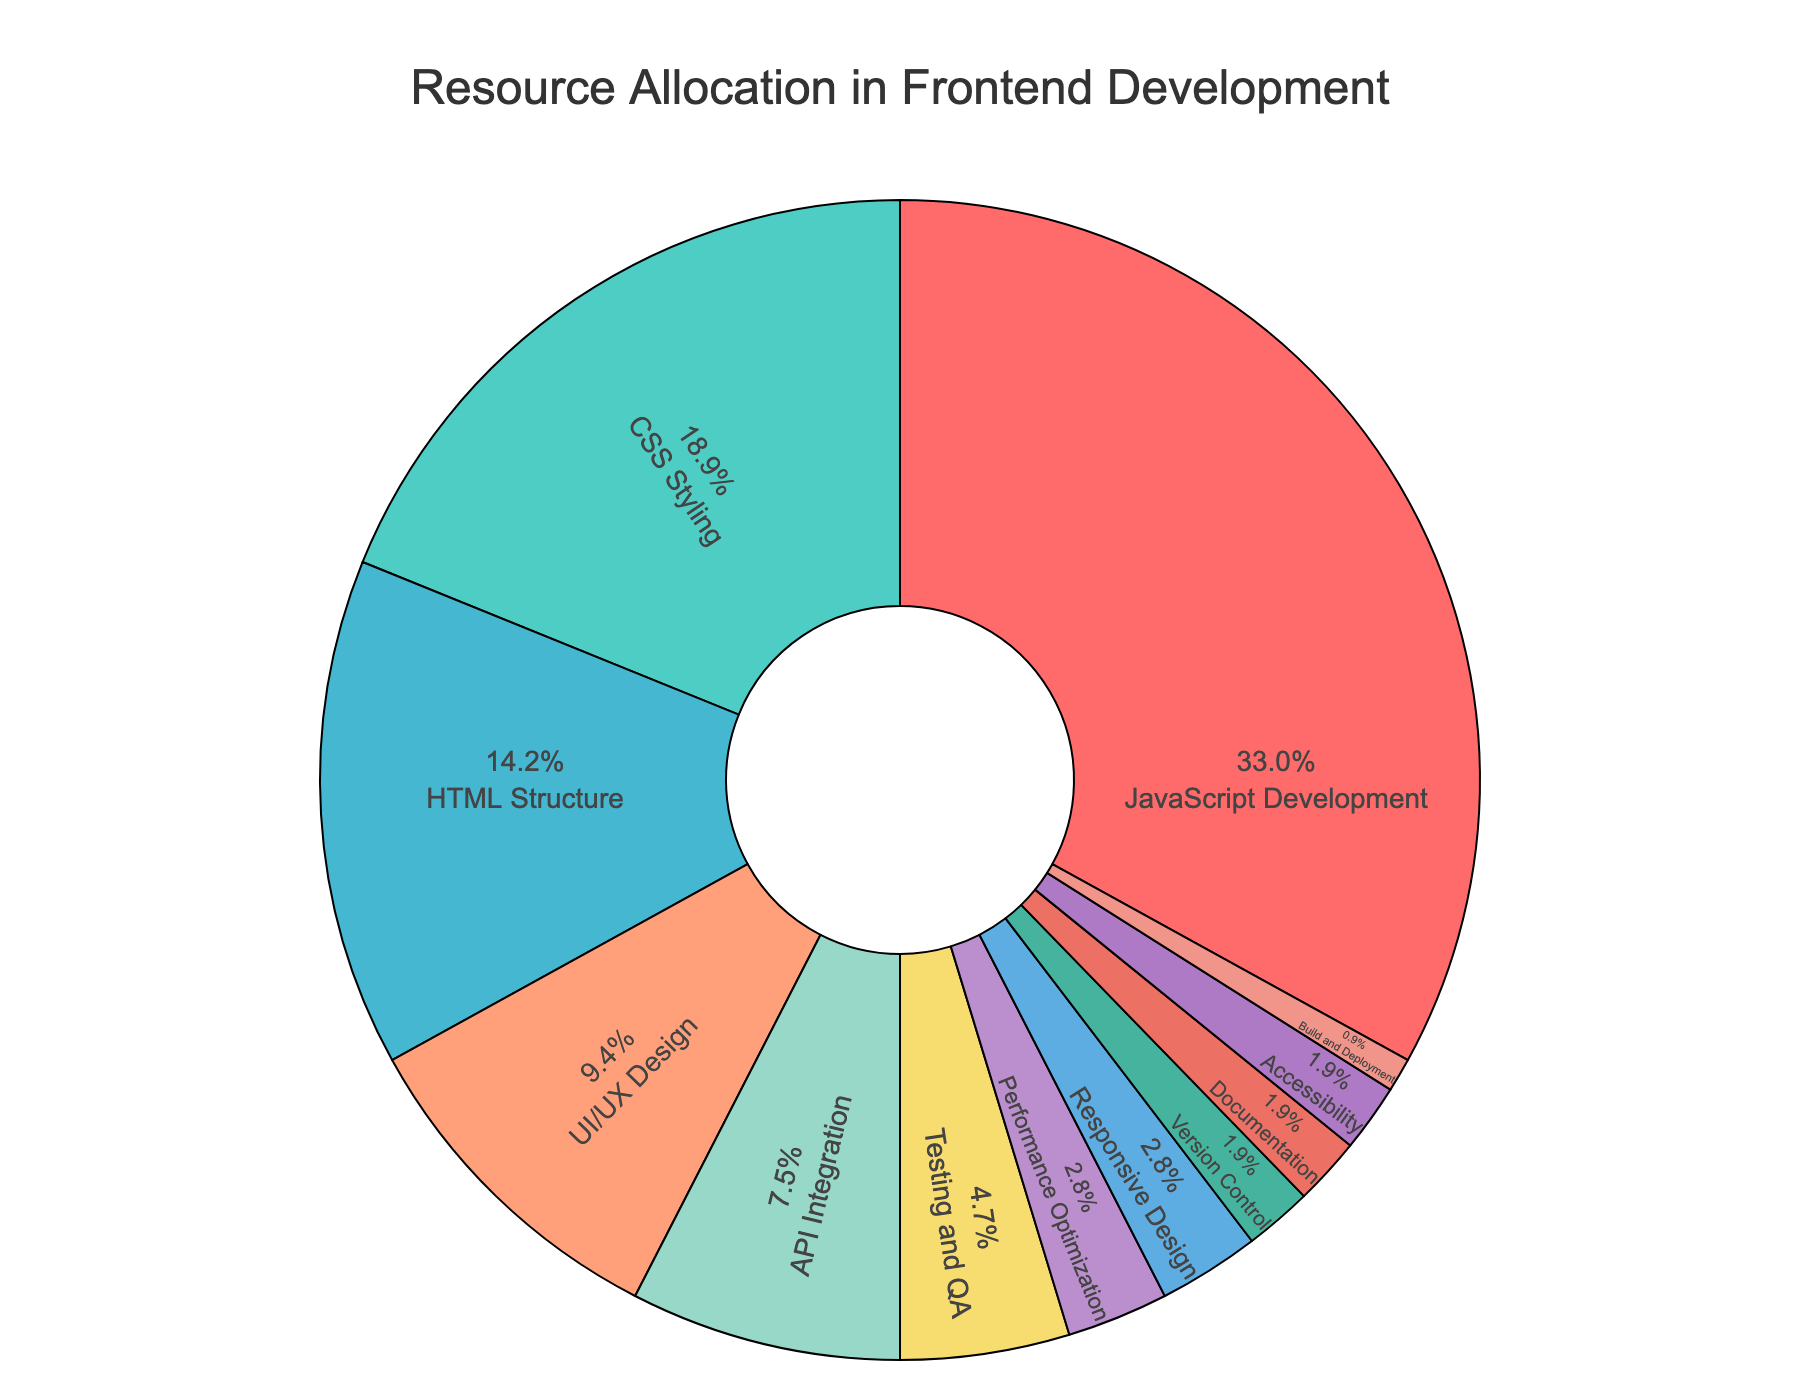Which resource has the largest allocation? Look for the section with the highest percentage in the pie chart. "JavaScript Development" has the largest portion.
Answer: JavaScript Development How much larger is the allocation for JavaScript Development compared to CSS Styling? JavaScript Development is allocated 35%, and CSS Styling is allocated 20%. Subtract 20% from 35% to get the difference.
Answer: 15% What is the total percentage allocated to UI/UX Design, Testing and QA, and Performance Optimization combined? Add the percentages for UI/UX Design (10%), Testing and QA (5%), and Performance Optimization (3%). 10% + 5% + 3% = 18%.
Answer: 18% Which resource has the smallest allocation, and what is that percentage? Look for the section with the smallest percentage in the pie chart. "Build and Deployment" has the smallest portion with 1%.
Answer: Build and Deployment, 1% Is the allocation for Documentation equal to the allocation for Accessibility? Check if both sections have the same percentage. Both Documentation and Accessibility are allocated 2%.
Answer: Yes How many resources are allocated exactly 2%? Count the number of sections that are marked with 2%. There are three: Version Control, Documentation, and Accessibility.
Answer: 3 What is the combined allocation of resources excluding JavaScript Development and CSS Styling? Sum the percentages of all resources other than JavaScript Development (35%) and CSS Styling (20%). This leaves us with 15% + 10% + 8% + 5% + 3% + 3% + 2% + 2% + 2% + 1%. This sums up to 51%.
Answer: 51% Which resource categories have less than 5% allocation and how many are they? Identify sections that have percentages lower than 5%. These are Performance Optimization (3%), Responsive Design (3%), Version Control (2%), Documentation (2%), Accessibility (2%), and Build and Deployment (1%). Total count is 6.
Answer: 6 Are there more resources allocated at or above 10% than those allocated below 10%? Count the number of sections at or above 10% (JavaScript Development: 35%, CSS Styling: 20%, HTML Structure: 15%, UI/UX Design: 10%). This is a total of 4. Now count the ones below 10%: API Integration (8%), Testing and QA (5%), Performance Optimization (3%), Responsive Design (3%), Version Control (2%), Documentation (2%), Accessibility (2%), Build and Deployment (1%). Total is 8. There are fewer with at or above 10% allocation.
Answer: No How much more is allocated for HTML Structure compared to the combined allocation for Build and Deployment, Documentation, and Accessibility? HTML Structure is allocated 15%. Add the percentages for Build and Deployment (1%), Documentation (2%), and Accessibility (2%). This totals 1% + 2% + 2% = 5%. Subtract 5% from 15%.
Answer: 10% 